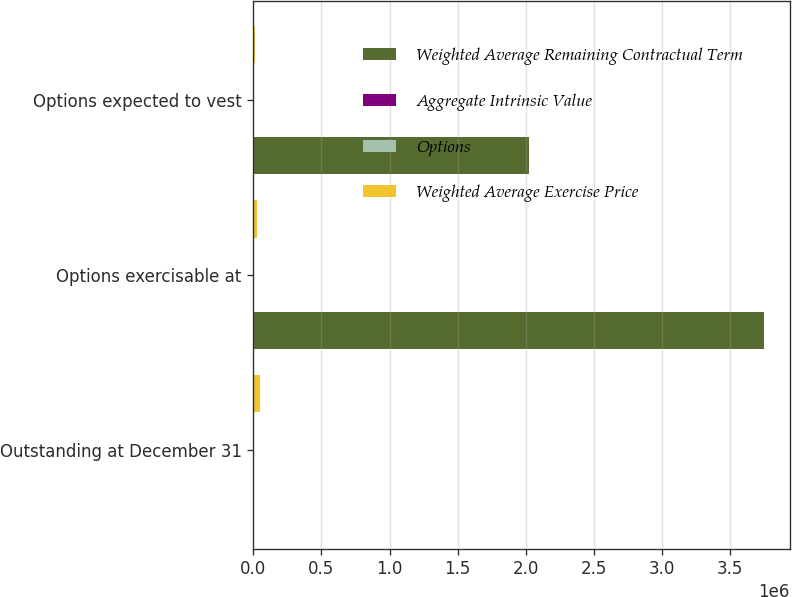Convert chart. <chart><loc_0><loc_0><loc_500><loc_500><stacked_bar_chart><ecel><fcel>Outstanding at December 31<fcel>Options exercisable at<fcel>Options expected to vest<nl><fcel>Weighted Average Remaining Contractual Term<fcel>23.42<fcel>3.74867e+06<fcel>2.02135e+06<nl><fcel>Aggregate Intrinsic Value<fcel>23.39<fcel>23.42<fcel>23.35<nl><fcel>Options<fcel>5.88<fcel>5.11<fcel>7.26<nl><fcel>Weighted Average Exercise Price<fcel>45908<fcel>29251<fcel>15572<nl></chart> 